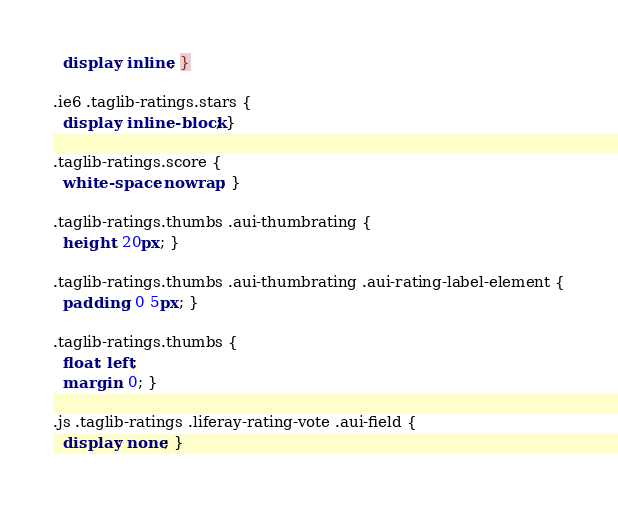Convert code to text. <code><loc_0><loc_0><loc_500><loc_500><_CSS_>  display: inline; }

.ie6 .taglib-ratings.stars {
  display: inline-block; }

.taglib-ratings.score {
  white-space: nowrap; }

.taglib-ratings.thumbs .aui-thumbrating {
  height: 20px; }

.taglib-ratings.thumbs .aui-thumbrating .aui-rating-label-element {
  padding: 0 5px; }

.taglib-ratings.thumbs {
  float: left;
  margin: 0; }

.js .taglib-ratings .liferay-rating-vote .aui-field {
  display: none; }

</code> 